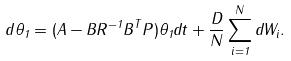<formula> <loc_0><loc_0><loc_500><loc_500>d \theta _ { 1 } = ( A - B R ^ { - 1 } B ^ { T } P ) \theta _ { 1 } d t + \frac { D } { N } \sum _ { i = 1 } ^ { N } d W _ { i } .</formula> 